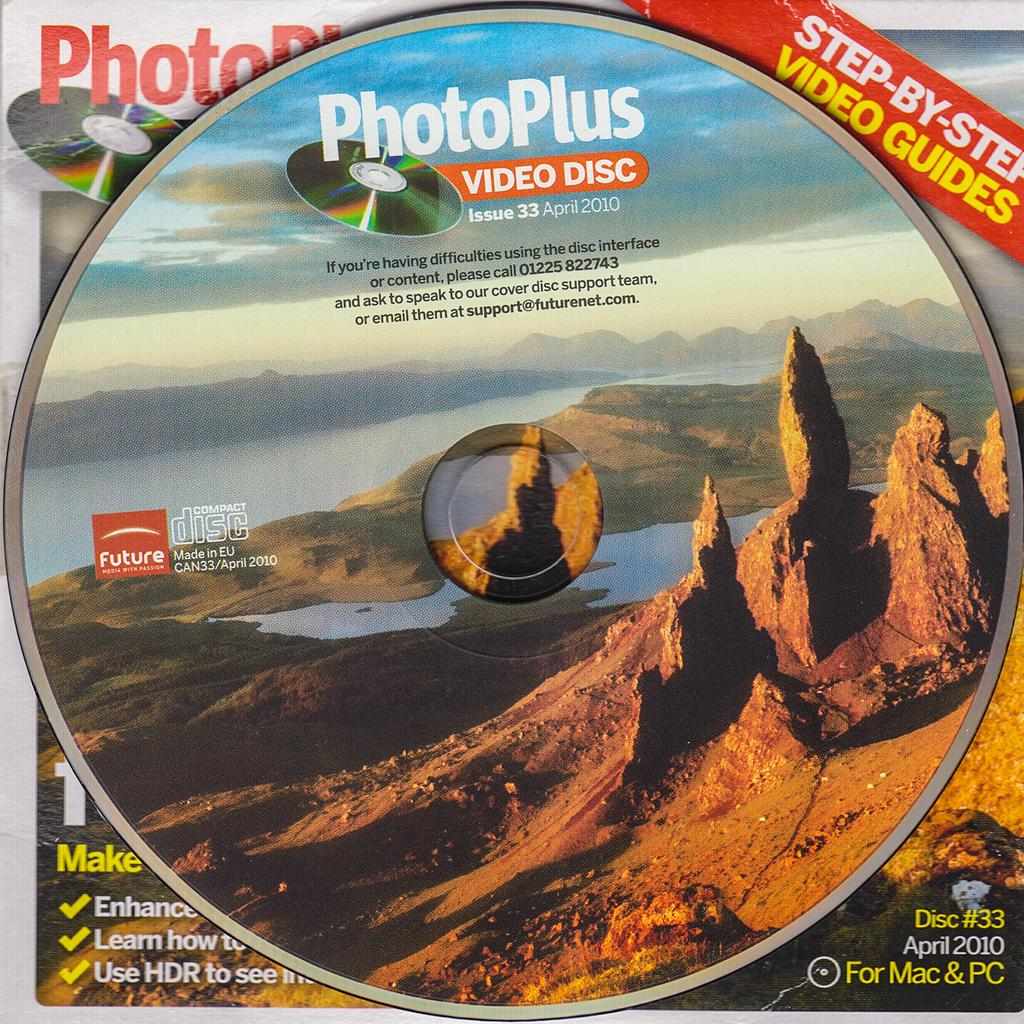<image>
Relay a brief, clear account of the picture shown. A PhotoPlus Video Disc shows a picture of mountains and a valley. 